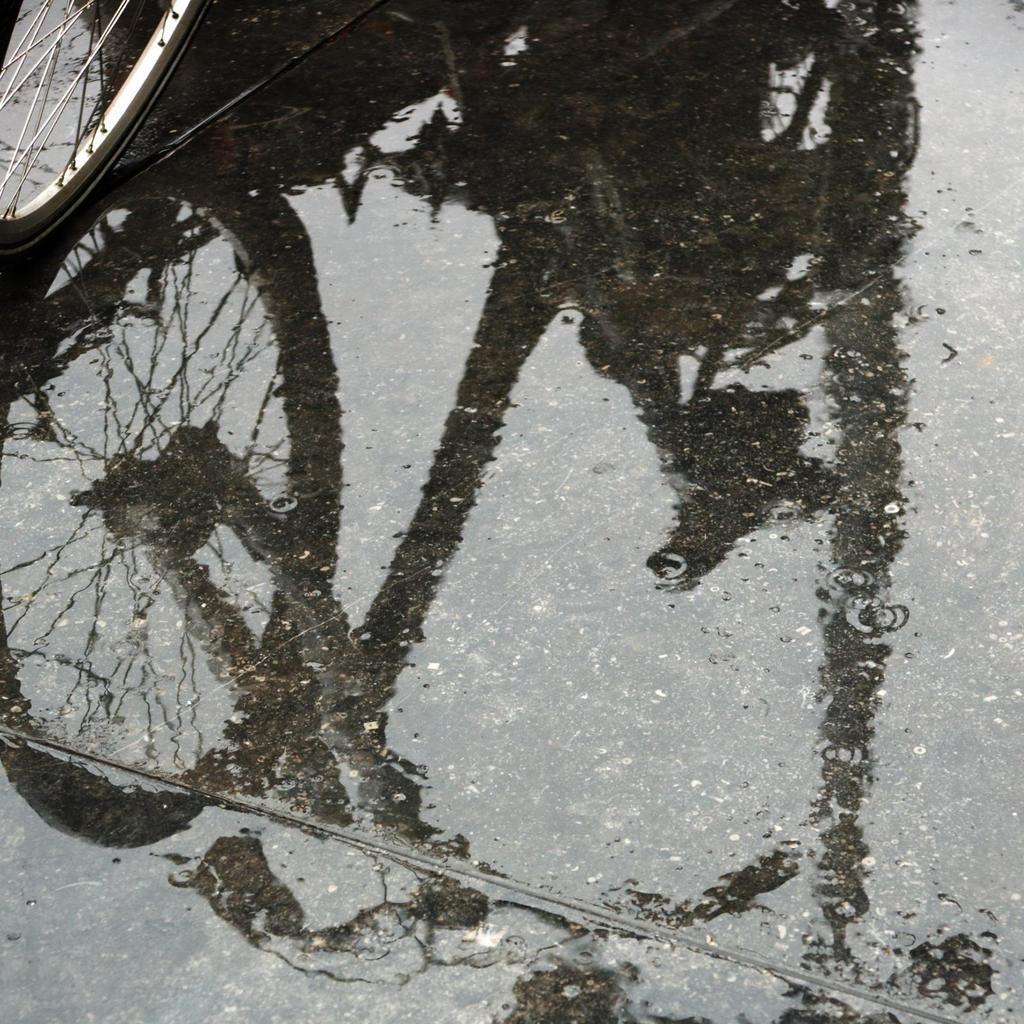Could you give a brief overview of what you see in this image? In this image I can see there is a wheel on the left side and there is a reflection of a bicycle on the water on the floor. 